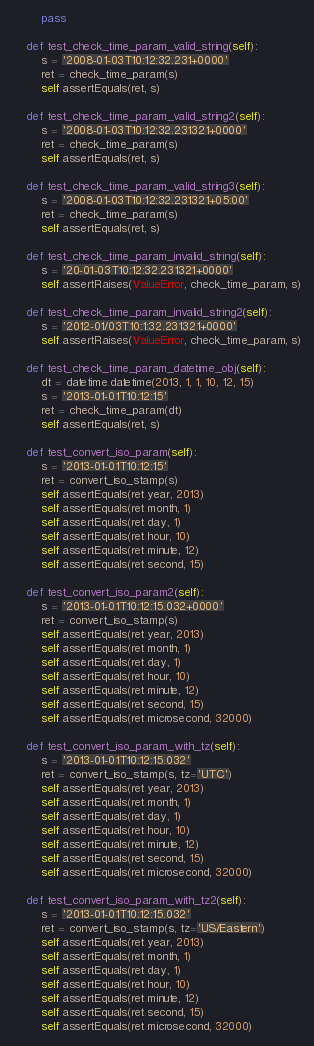<code> <loc_0><loc_0><loc_500><loc_500><_Python_>        pass

    def test_check_time_param_valid_string(self):
        s = '2008-01-03T10:12:32.231+0000'
        ret = check_time_param(s)
        self.assertEquals(ret, s)

    def test_check_time_param_valid_string2(self):
        s = '2008-01-03T10:12:32.231321+0000'
        ret = check_time_param(s)
        self.assertEquals(ret, s)

    def test_check_time_param_valid_string3(self):
        s = '2008-01-03T10:12:32.231321+05:00'
        ret = check_time_param(s)
        self.assertEquals(ret, s)

    def test_check_time_param_invalid_string(self):
        s = '20-01-03T10:12:32.231321+0000'
        self.assertRaises(ValueError, check_time_param, s)

    def test_check_time_param_invalid_string2(self):
        s = '2012-01/03T10:1:32.231321+0000'
        self.assertRaises(ValueError, check_time_param, s)

    def test_check_time_param_datetime_obj(self):
        dt = datetime.datetime(2013, 1, 1, 10, 12, 15)
        s = '2013-01-01T10:12:15'
        ret = check_time_param(dt)
        self.assertEquals(ret, s)

    def test_convert_iso_param(self):
        s = '2013-01-01T10:12:15'
        ret = convert_iso_stamp(s)
        self.assertEquals(ret.year, 2013)
        self.assertEquals(ret.month, 1)
        self.assertEquals(ret.day, 1)
        self.assertEquals(ret.hour, 10)
        self.assertEquals(ret.minute, 12)
        self.assertEquals(ret.second, 15)

    def test_convert_iso_param2(self):
        s = '2013-01-01T10:12:15.032+0000'
        ret = convert_iso_stamp(s)
        self.assertEquals(ret.year, 2013)
        self.assertEquals(ret.month, 1)
        self.assertEquals(ret.day, 1)
        self.assertEquals(ret.hour, 10)
        self.assertEquals(ret.minute, 12)
        self.assertEquals(ret.second, 15)
        self.assertEquals(ret.microsecond, 32000)

    def test_convert_iso_param_with_tz(self):
        s = '2013-01-01T10:12:15.032'
        ret = convert_iso_stamp(s, tz='UTC')
        self.assertEquals(ret.year, 2013)
        self.assertEquals(ret.month, 1)
        self.assertEquals(ret.day, 1)
        self.assertEquals(ret.hour, 10)
        self.assertEquals(ret.minute, 12)
        self.assertEquals(ret.second, 15)
        self.assertEquals(ret.microsecond, 32000)

    def test_convert_iso_param_with_tz2(self):
        s = '2013-01-01T10:12:15.032'
        ret = convert_iso_stamp(s, tz='US/Eastern')
        self.assertEquals(ret.year, 2013)
        self.assertEquals(ret.month, 1)
        self.assertEquals(ret.day, 1)
        self.assertEquals(ret.hour, 10)
        self.assertEquals(ret.minute, 12)
        self.assertEquals(ret.second, 15)
        self.assertEquals(ret.microsecond, 32000)
</code> 